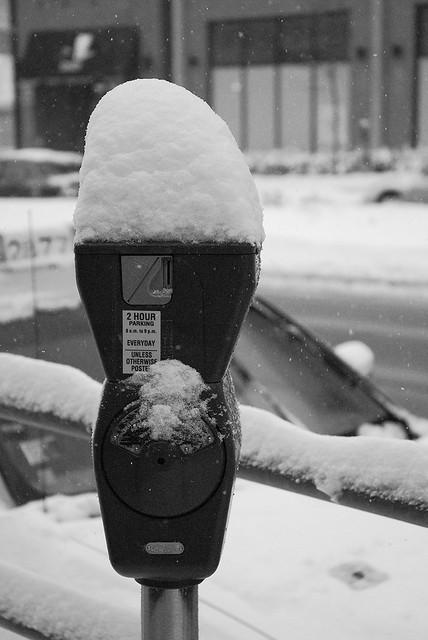What is behind the parking meter?
Write a very short answer. Car. Is it summer time?
Short answer required. No. Is the road clear?
Quick response, please. No. 